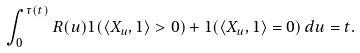<formula> <loc_0><loc_0><loc_500><loc_500>\int _ { 0 } ^ { \tau ( t ) } R ( u ) 1 ( \langle X _ { u } , 1 \rangle > 0 ) + 1 ( \langle X _ { u } , 1 \rangle = 0 ) \, d u = t .</formula> 